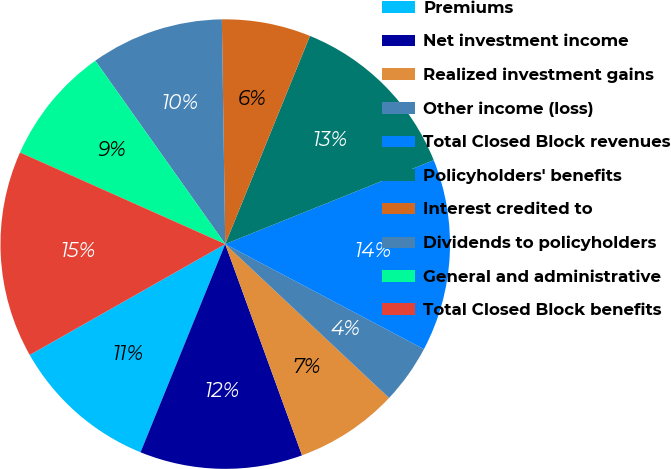Convert chart. <chart><loc_0><loc_0><loc_500><loc_500><pie_chart><fcel>Premiums<fcel>Net investment income<fcel>Realized investment gains<fcel>Other income (loss)<fcel>Total Closed Block revenues<fcel>Policyholders' benefits<fcel>Interest credited to<fcel>Dividends to policyholders<fcel>General and administrative<fcel>Total Closed Block benefits<nl><fcel>10.64%<fcel>11.7%<fcel>7.45%<fcel>4.26%<fcel>13.83%<fcel>12.76%<fcel>6.39%<fcel>9.57%<fcel>8.51%<fcel>14.89%<nl></chart> 